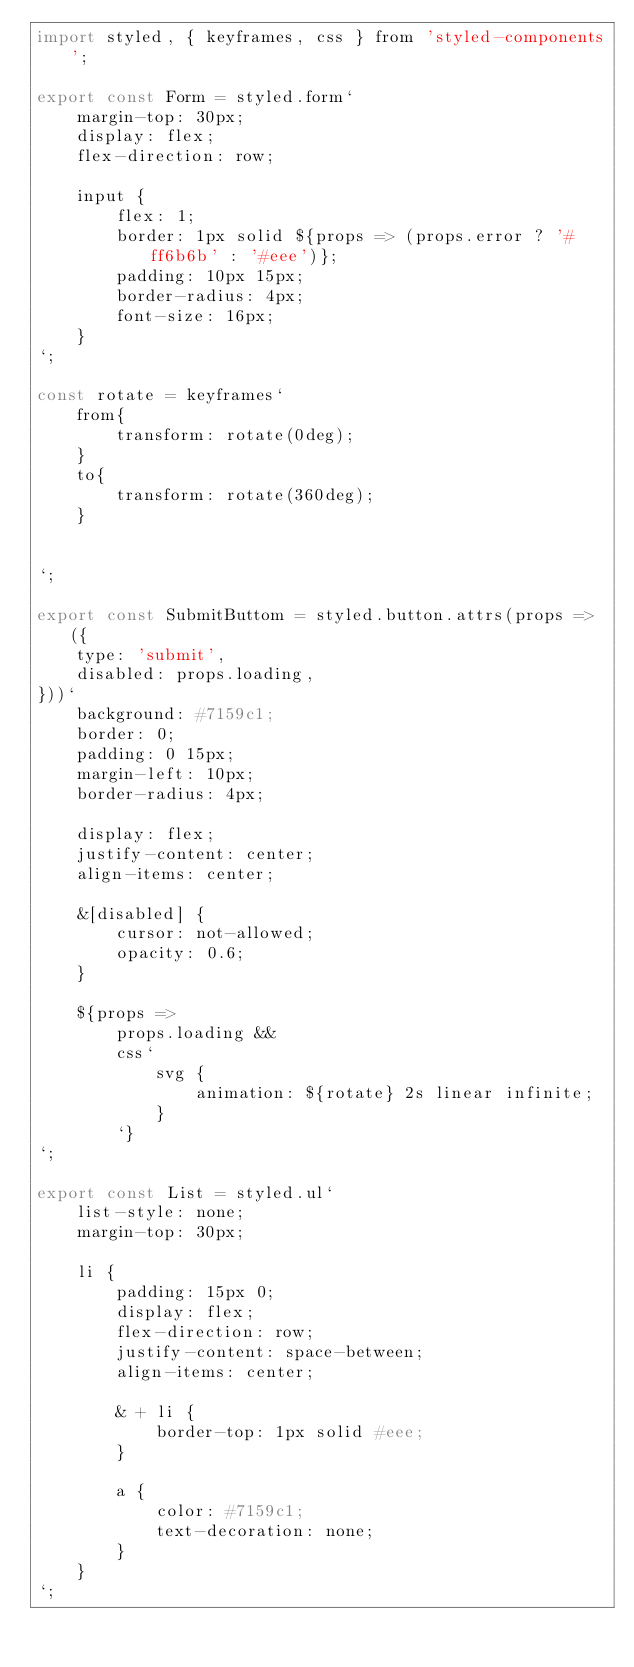Convert code to text. <code><loc_0><loc_0><loc_500><loc_500><_JavaScript_>import styled, { keyframes, css } from 'styled-components';

export const Form = styled.form`
    margin-top: 30px;
    display: flex;
    flex-direction: row;

    input {
        flex: 1;
        border: 1px solid ${props => (props.error ? '#ff6b6b' : '#eee')};
        padding: 10px 15px;
        border-radius: 4px;
        font-size: 16px;
    }
`;

const rotate = keyframes`
    from{
        transform: rotate(0deg);
    }
    to{
        transform: rotate(360deg);
    }


`;

export const SubmitButtom = styled.button.attrs(props => ({
    type: 'submit',
    disabled: props.loading,
}))`
    background: #7159c1;
    border: 0;
    padding: 0 15px;
    margin-left: 10px;
    border-radius: 4px;

    display: flex;
    justify-content: center;
    align-items: center;

    &[disabled] {
        cursor: not-allowed;
        opacity: 0.6;
    }

    ${props =>
        props.loading &&
        css`
            svg {
                animation: ${rotate} 2s linear infinite;
            }
        `}
`;

export const List = styled.ul`
    list-style: none;
    margin-top: 30px;

    li {
        padding: 15px 0;
        display: flex;
        flex-direction: row;
        justify-content: space-between;
        align-items: center;

        & + li {
            border-top: 1px solid #eee;
        }

        a {
            color: #7159c1;
            text-decoration: none;
        }
    }
`;
</code> 